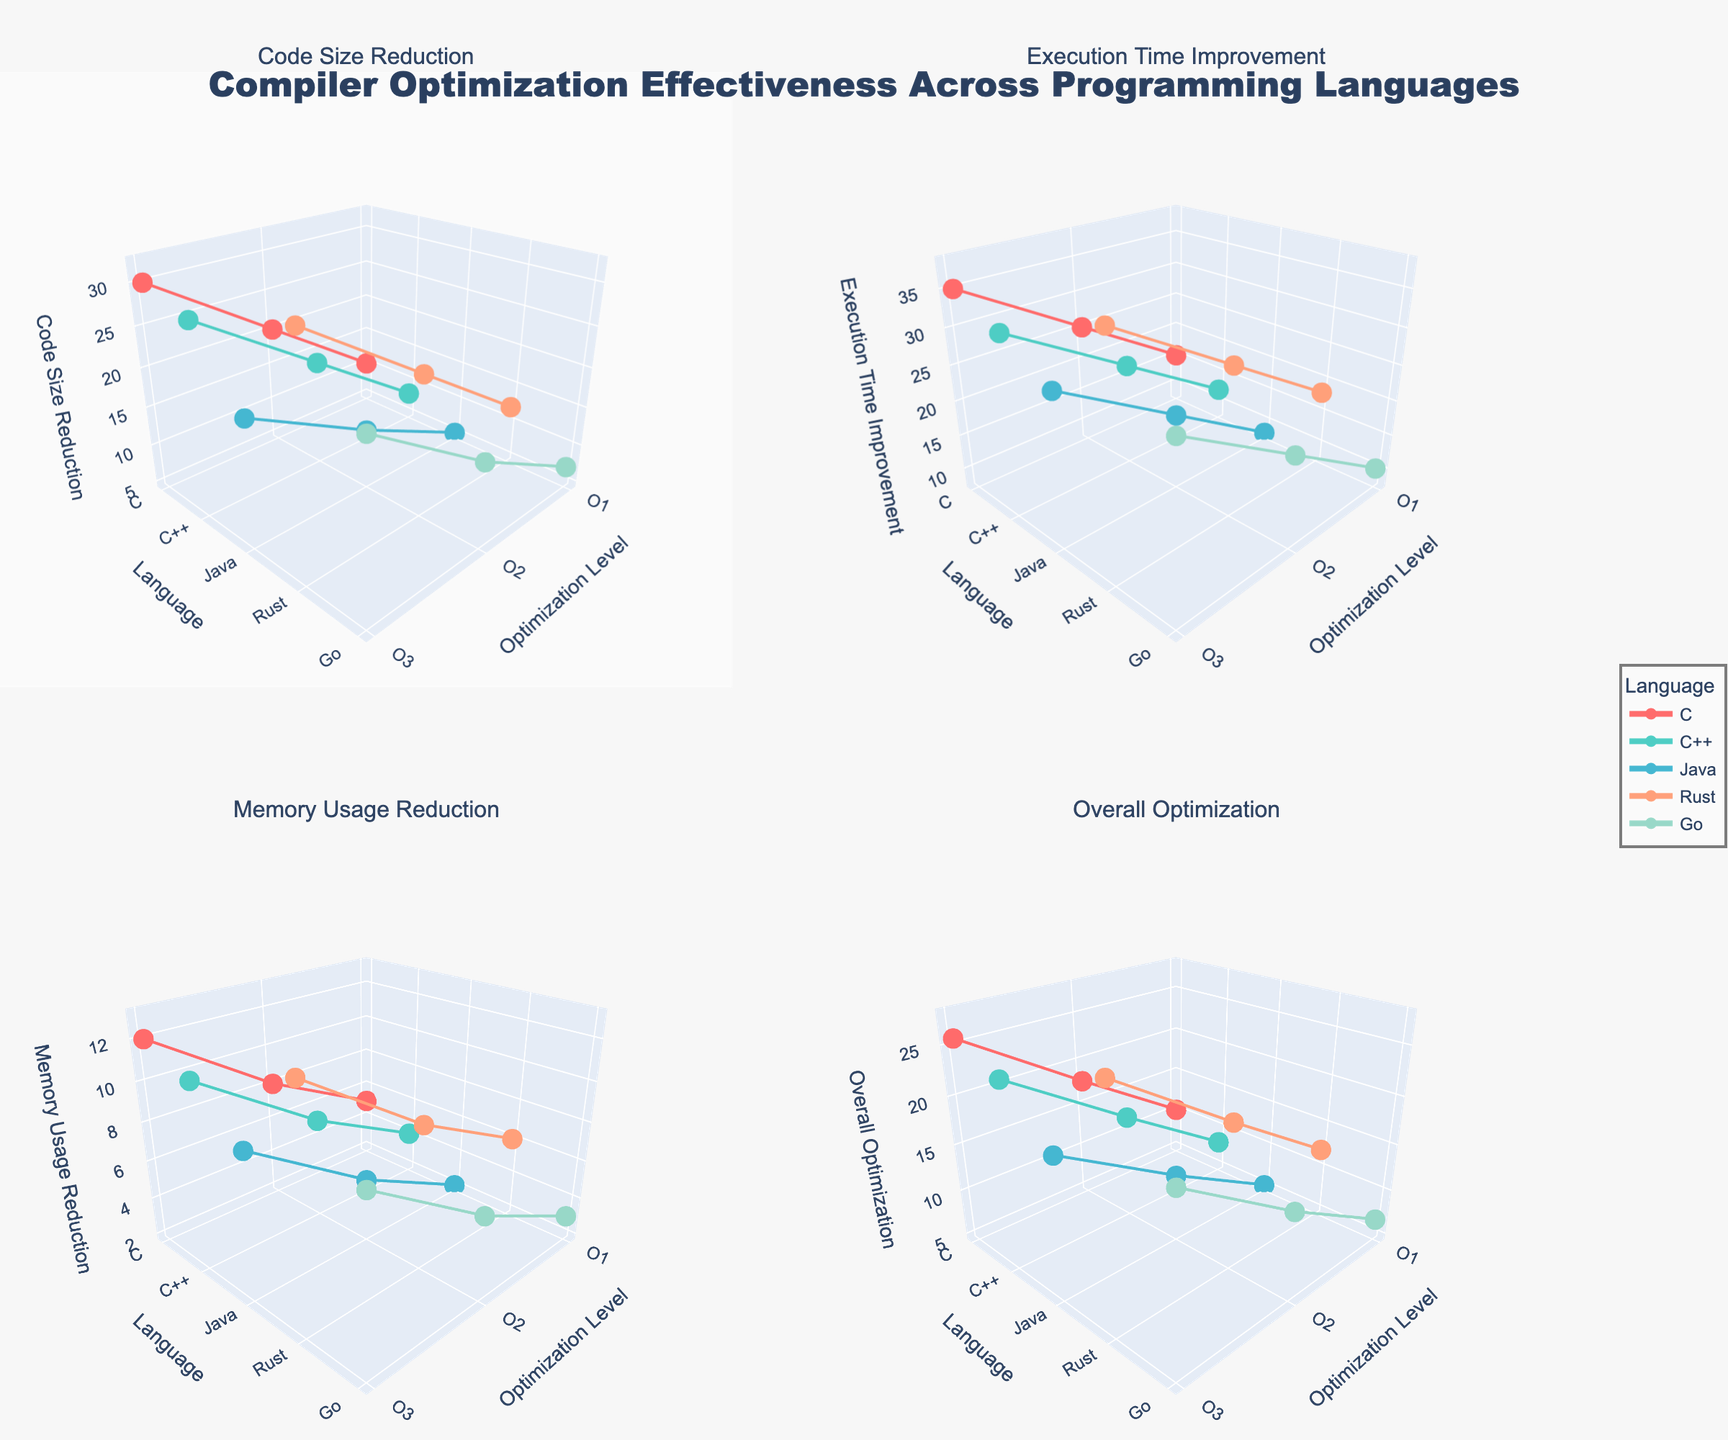How many optimization levels are represented for each programming language? Each subplot shows three major optimization levels (O1, O2, O3) for each programming language which can be identified by the number of data points in the plots for each language. Thus, each plot shows three distinct optimization levels for all languages.
Answer: 3 Which language exhibits the highest code size reduction at the highest optimization level (O3)? Refer to the "Code Size Reduction" subplot and look at the highest data points (O3) for each language. Rust at O3 has the highest point with a reduction of 32%.
Answer: Rust What is the average memory usage reduction for Java across all optimization levels? Find Java's memory usage reduction values from the "Memory Usage Reduction" subplot for O1, O2, and O3 (2, 5, 9). Calculate the average: (2 + 5 + 9) / 3 = 16 / 3 = 5.33.
Answer: 5.33 Compare the execution time improvement for Go at O1 and Rust at O1. Which one is better? Check the "Execution Time Improvement" subplot and compare Go's O1 value (10) with Rust's O1 value (18). Rust's execution time improvement at O1 is higher than Go's.
Answer: Rust Which axis represents the programming languages across all subplots? All subplots have the names of the programming languages depicted along their y-axes, which can be visualized clearly in any subplot.
Answer: y-axis For C++, what is the difference in code size reduction between optimization levels O2 and O3? Locate the values in the "Code Size Reduction" subplot. C++ at O2 shows a reduction of 18% and at O3 shows 28%. The difference is 28% - 18% = 10%.
Answer: 10% What is the overall optimization value for Rust at O2 level? In the "Overall Optimization" subplot, find the value for Rust at O2. Calculate the mean across all metrics for Rust at O2: (22 + 28 + 9) / 3 = 59 / 3 = 19.67.
Answer: 19.67 Which language achieves the lowest execution time improvement at the highest optimization level? Refer to the "Execution Time Improvement" subplot. For optimization level O3, Java has the lowest improvement value of 28.
Answer: Java Do any two languages have the same code size reduction at the O2 optimization level? Examine the "Code Size Reduction" subplot and compare values at O2 optimization level. Both C++ and Rust have very close values (C++ at 18% and Rust at 22%), but none are exactly the same.
Answer: No 